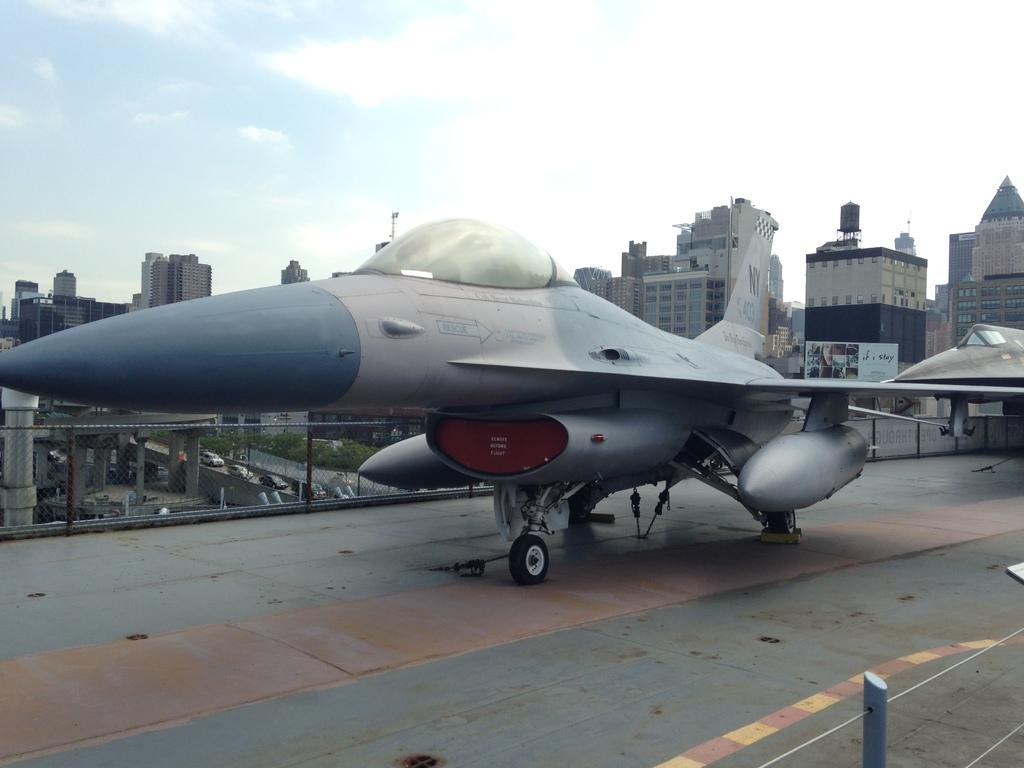What is the main subject in the center of the image? There is an aircraft in the center of the image. What can be seen in the background of the image? There are trees and buildings in the background of the image. What is visible at the top of the image? The sky is visible at the top of the image. What type of food is being prepared in the wilderness in the image? There is no food or wilderness present in the image; it features an aircraft and background elements such as trees and buildings. 